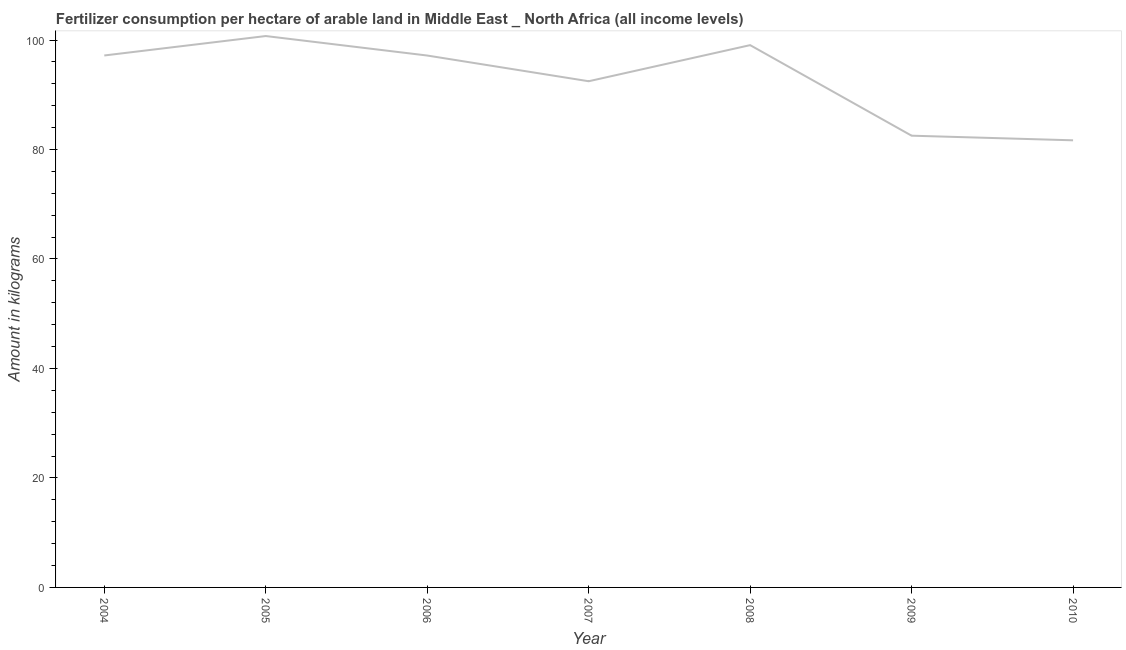What is the amount of fertilizer consumption in 2004?
Your response must be concise. 97.18. Across all years, what is the maximum amount of fertilizer consumption?
Keep it short and to the point. 100.73. Across all years, what is the minimum amount of fertilizer consumption?
Your answer should be compact. 81.68. What is the sum of the amount of fertilizer consumption?
Offer a terse response. 650.81. What is the difference between the amount of fertilizer consumption in 2007 and 2009?
Offer a very short reply. 9.95. What is the average amount of fertilizer consumption per year?
Give a very brief answer. 92.97. What is the median amount of fertilizer consumption?
Ensure brevity in your answer.  97.17. In how many years, is the amount of fertilizer consumption greater than 64 kg?
Ensure brevity in your answer.  7. What is the ratio of the amount of fertilizer consumption in 2005 to that in 2010?
Give a very brief answer. 1.23. Is the difference between the amount of fertilizer consumption in 2008 and 2009 greater than the difference between any two years?
Your answer should be compact. No. What is the difference between the highest and the second highest amount of fertilizer consumption?
Your answer should be very brief. 1.66. Is the sum of the amount of fertilizer consumption in 2005 and 2010 greater than the maximum amount of fertilizer consumption across all years?
Provide a succinct answer. Yes. What is the difference between the highest and the lowest amount of fertilizer consumption?
Keep it short and to the point. 19.05. In how many years, is the amount of fertilizer consumption greater than the average amount of fertilizer consumption taken over all years?
Provide a succinct answer. 4. Does the amount of fertilizer consumption monotonically increase over the years?
Keep it short and to the point. No. Are the values on the major ticks of Y-axis written in scientific E-notation?
Provide a succinct answer. No. What is the title of the graph?
Give a very brief answer. Fertilizer consumption per hectare of arable land in Middle East _ North Africa (all income levels) . What is the label or title of the Y-axis?
Your answer should be very brief. Amount in kilograms. What is the Amount in kilograms in 2004?
Offer a terse response. 97.18. What is the Amount in kilograms of 2005?
Offer a terse response. 100.73. What is the Amount in kilograms in 2006?
Provide a short and direct response. 97.17. What is the Amount in kilograms in 2007?
Make the answer very short. 92.47. What is the Amount in kilograms in 2008?
Your response must be concise. 99.07. What is the Amount in kilograms of 2009?
Keep it short and to the point. 82.52. What is the Amount in kilograms of 2010?
Keep it short and to the point. 81.68. What is the difference between the Amount in kilograms in 2004 and 2005?
Your answer should be very brief. -3.55. What is the difference between the Amount in kilograms in 2004 and 2006?
Ensure brevity in your answer.  0.01. What is the difference between the Amount in kilograms in 2004 and 2007?
Make the answer very short. 4.7. What is the difference between the Amount in kilograms in 2004 and 2008?
Give a very brief answer. -1.89. What is the difference between the Amount in kilograms in 2004 and 2009?
Keep it short and to the point. 14.65. What is the difference between the Amount in kilograms in 2004 and 2010?
Offer a very short reply. 15.5. What is the difference between the Amount in kilograms in 2005 and 2006?
Your answer should be compact. 3.56. What is the difference between the Amount in kilograms in 2005 and 2007?
Offer a terse response. 8.26. What is the difference between the Amount in kilograms in 2005 and 2008?
Your response must be concise. 1.66. What is the difference between the Amount in kilograms in 2005 and 2009?
Make the answer very short. 18.2. What is the difference between the Amount in kilograms in 2005 and 2010?
Provide a succinct answer. 19.05. What is the difference between the Amount in kilograms in 2006 and 2007?
Offer a very short reply. 4.7. What is the difference between the Amount in kilograms in 2006 and 2008?
Offer a very short reply. -1.9. What is the difference between the Amount in kilograms in 2006 and 2009?
Ensure brevity in your answer.  14.64. What is the difference between the Amount in kilograms in 2006 and 2010?
Offer a terse response. 15.49. What is the difference between the Amount in kilograms in 2007 and 2008?
Give a very brief answer. -6.6. What is the difference between the Amount in kilograms in 2007 and 2009?
Provide a short and direct response. 9.95. What is the difference between the Amount in kilograms in 2007 and 2010?
Your answer should be compact. 10.79. What is the difference between the Amount in kilograms in 2008 and 2009?
Your answer should be very brief. 16.54. What is the difference between the Amount in kilograms in 2008 and 2010?
Your answer should be very brief. 17.39. What is the difference between the Amount in kilograms in 2009 and 2010?
Keep it short and to the point. 0.85. What is the ratio of the Amount in kilograms in 2004 to that in 2007?
Give a very brief answer. 1.05. What is the ratio of the Amount in kilograms in 2004 to that in 2009?
Your response must be concise. 1.18. What is the ratio of the Amount in kilograms in 2004 to that in 2010?
Provide a succinct answer. 1.19. What is the ratio of the Amount in kilograms in 2005 to that in 2006?
Your response must be concise. 1.04. What is the ratio of the Amount in kilograms in 2005 to that in 2007?
Ensure brevity in your answer.  1.09. What is the ratio of the Amount in kilograms in 2005 to that in 2008?
Ensure brevity in your answer.  1.02. What is the ratio of the Amount in kilograms in 2005 to that in 2009?
Make the answer very short. 1.22. What is the ratio of the Amount in kilograms in 2005 to that in 2010?
Provide a succinct answer. 1.23. What is the ratio of the Amount in kilograms in 2006 to that in 2007?
Give a very brief answer. 1.05. What is the ratio of the Amount in kilograms in 2006 to that in 2008?
Give a very brief answer. 0.98. What is the ratio of the Amount in kilograms in 2006 to that in 2009?
Your answer should be very brief. 1.18. What is the ratio of the Amount in kilograms in 2006 to that in 2010?
Give a very brief answer. 1.19. What is the ratio of the Amount in kilograms in 2007 to that in 2008?
Your answer should be compact. 0.93. What is the ratio of the Amount in kilograms in 2007 to that in 2009?
Keep it short and to the point. 1.12. What is the ratio of the Amount in kilograms in 2007 to that in 2010?
Your answer should be very brief. 1.13. What is the ratio of the Amount in kilograms in 2008 to that in 2010?
Give a very brief answer. 1.21. What is the ratio of the Amount in kilograms in 2009 to that in 2010?
Offer a very short reply. 1.01. 